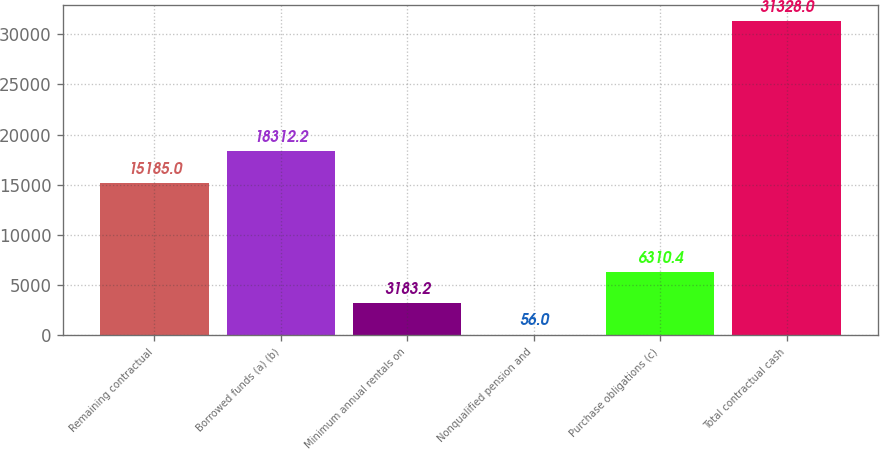Convert chart to OTSL. <chart><loc_0><loc_0><loc_500><loc_500><bar_chart><fcel>Remaining contractual<fcel>Borrowed funds (a) (b)<fcel>Minimum annual rentals on<fcel>Nonqualified pension and<fcel>Purchase obligations (c)<fcel>Total contractual cash<nl><fcel>15185<fcel>18312.2<fcel>3183.2<fcel>56<fcel>6310.4<fcel>31328<nl></chart> 